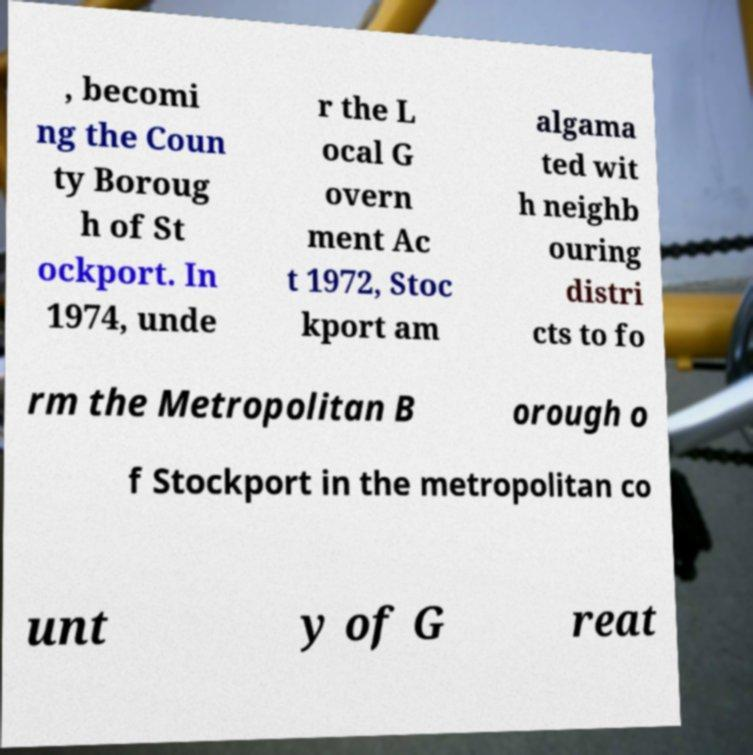Could you assist in decoding the text presented in this image and type it out clearly? , becomi ng the Coun ty Boroug h of St ockport. In 1974, unde r the L ocal G overn ment Ac t 1972, Stoc kport am algama ted wit h neighb ouring distri cts to fo rm the Metropolitan B orough o f Stockport in the metropolitan co unt y of G reat 